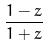Convert formula to latex. <formula><loc_0><loc_0><loc_500><loc_500>\frac { 1 - z } { 1 + z }</formula> 